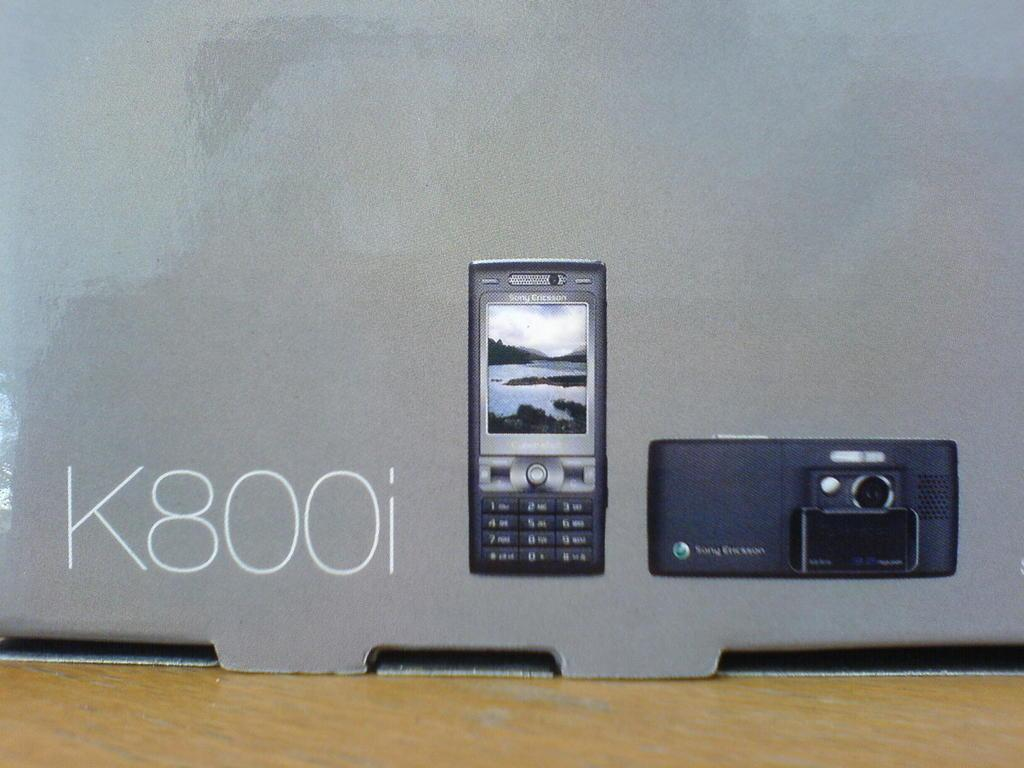<image>
Share a concise interpretation of the image provided. A box says K800i next to a photo of a phone and a photo of a camera. 